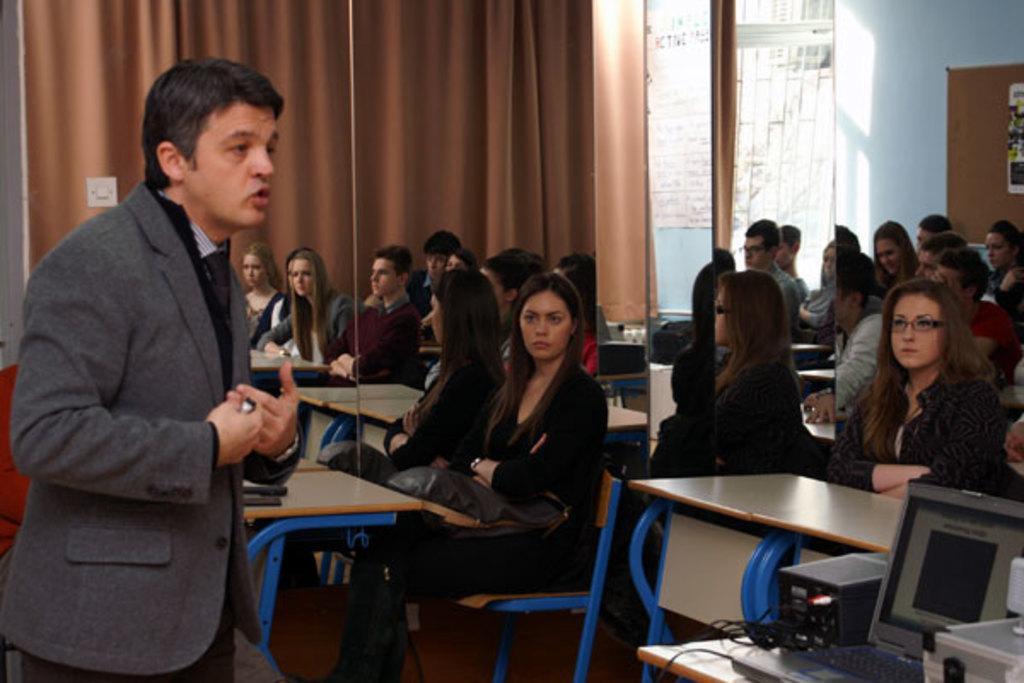Describe this image in one or two sentences. This is looking like a classroom. There are many people sitting on chair in front of them there are desks. in the left a person wearing grey jacket is talking something to the people. In the right there is a desktop. Here is a pillar. In the background there are curtains. 